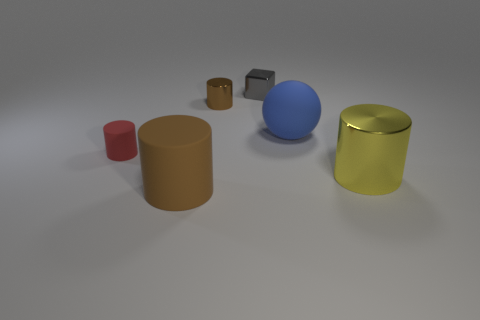What shape is the metal object in front of the large blue rubber ball?
Offer a very short reply. Cylinder. There is a brown object that is the same material as the yellow cylinder; what is its shape?
Offer a very short reply. Cylinder. Are there any other things that are the same shape as the red rubber object?
Your response must be concise. Yes. There is a gray thing; how many big cylinders are to the left of it?
Keep it short and to the point. 1. Are there the same number of small brown things right of the small block and small rubber cylinders?
Your answer should be compact. No. Is the tiny gray cube made of the same material as the small red cylinder?
Make the answer very short. No. What size is the rubber thing that is behind the brown rubber object and on the left side of the cube?
Your answer should be very brief. Small. What number of gray cylinders are the same size as the brown matte cylinder?
Offer a terse response. 0. There is a matte thing in front of the metal cylinder that is in front of the large blue rubber thing; what size is it?
Offer a terse response. Large. Does the rubber object that is on the right side of the small gray metal cube have the same shape as the brown object that is on the right side of the big brown rubber object?
Keep it short and to the point. No. 